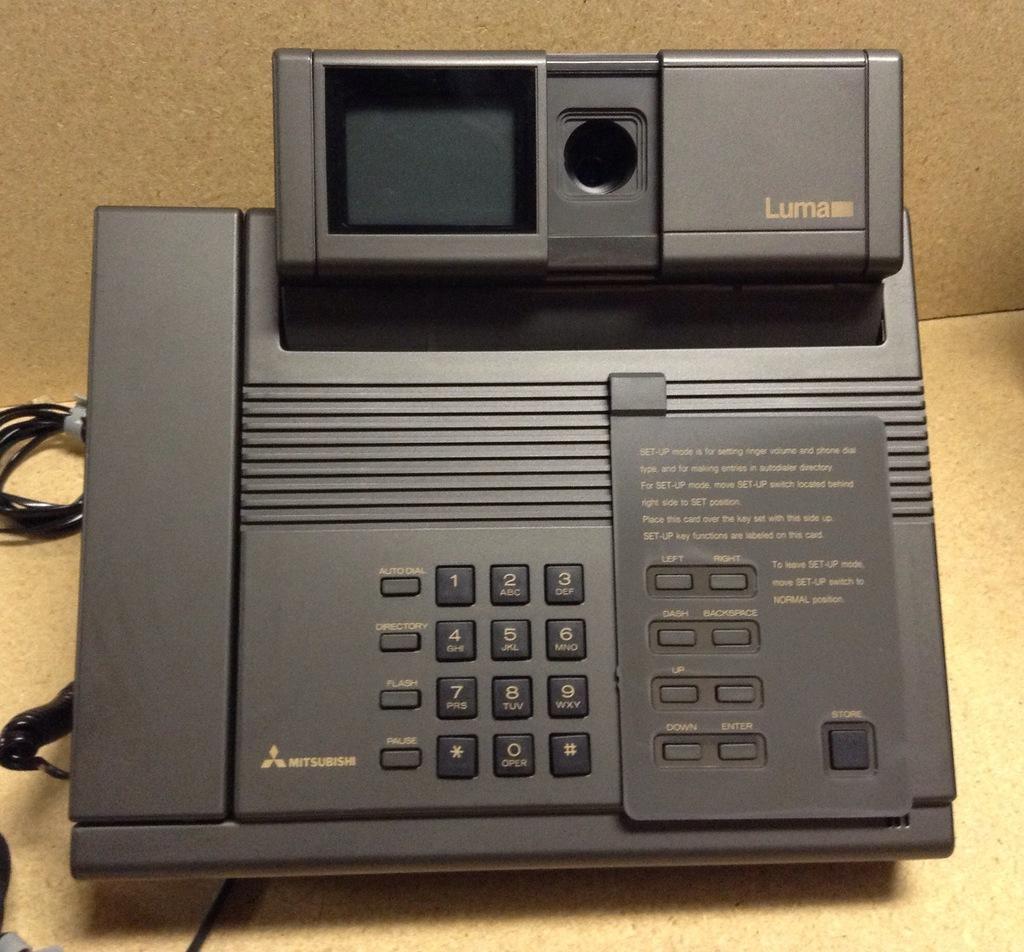Please provide a concise description of this image. I think this is the answering machine, which is black in color. These are the buttons attached to the machine. I can see the wires. 